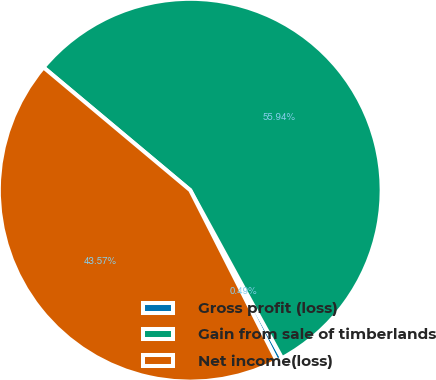<chart> <loc_0><loc_0><loc_500><loc_500><pie_chart><fcel>Gross profit (loss)<fcel>Gain from sale of timberlands<fcel>Net income(loss)<nl><fcel>0.49%<fcel>55.94%<fcel>43.57%<nl></chart> 